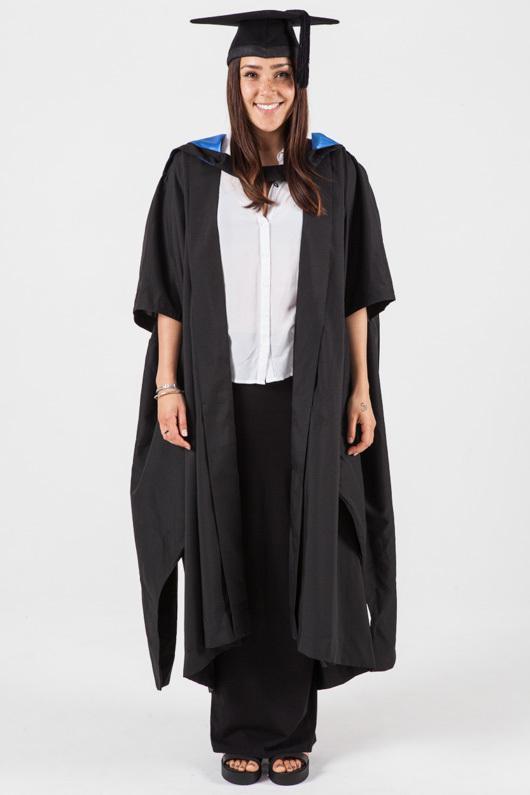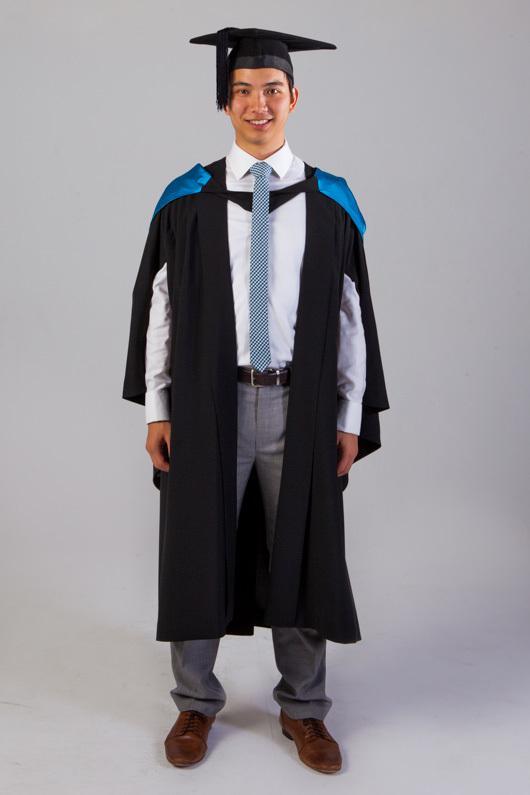The first image is the image on the left, the second image is the image on the right. Considering the images on both sides, is "The graduation attire in the image on the left is being modeled by a female." valid? Answer yes or no. Yes. The first image is the image on the left, the second image is the image on the right. Examine the images to the left and right. Is the description "Exactly one camera-facing female and one camera-facing male are shown modeling graduation attire." accurate? Answer yes or no. Yes. 